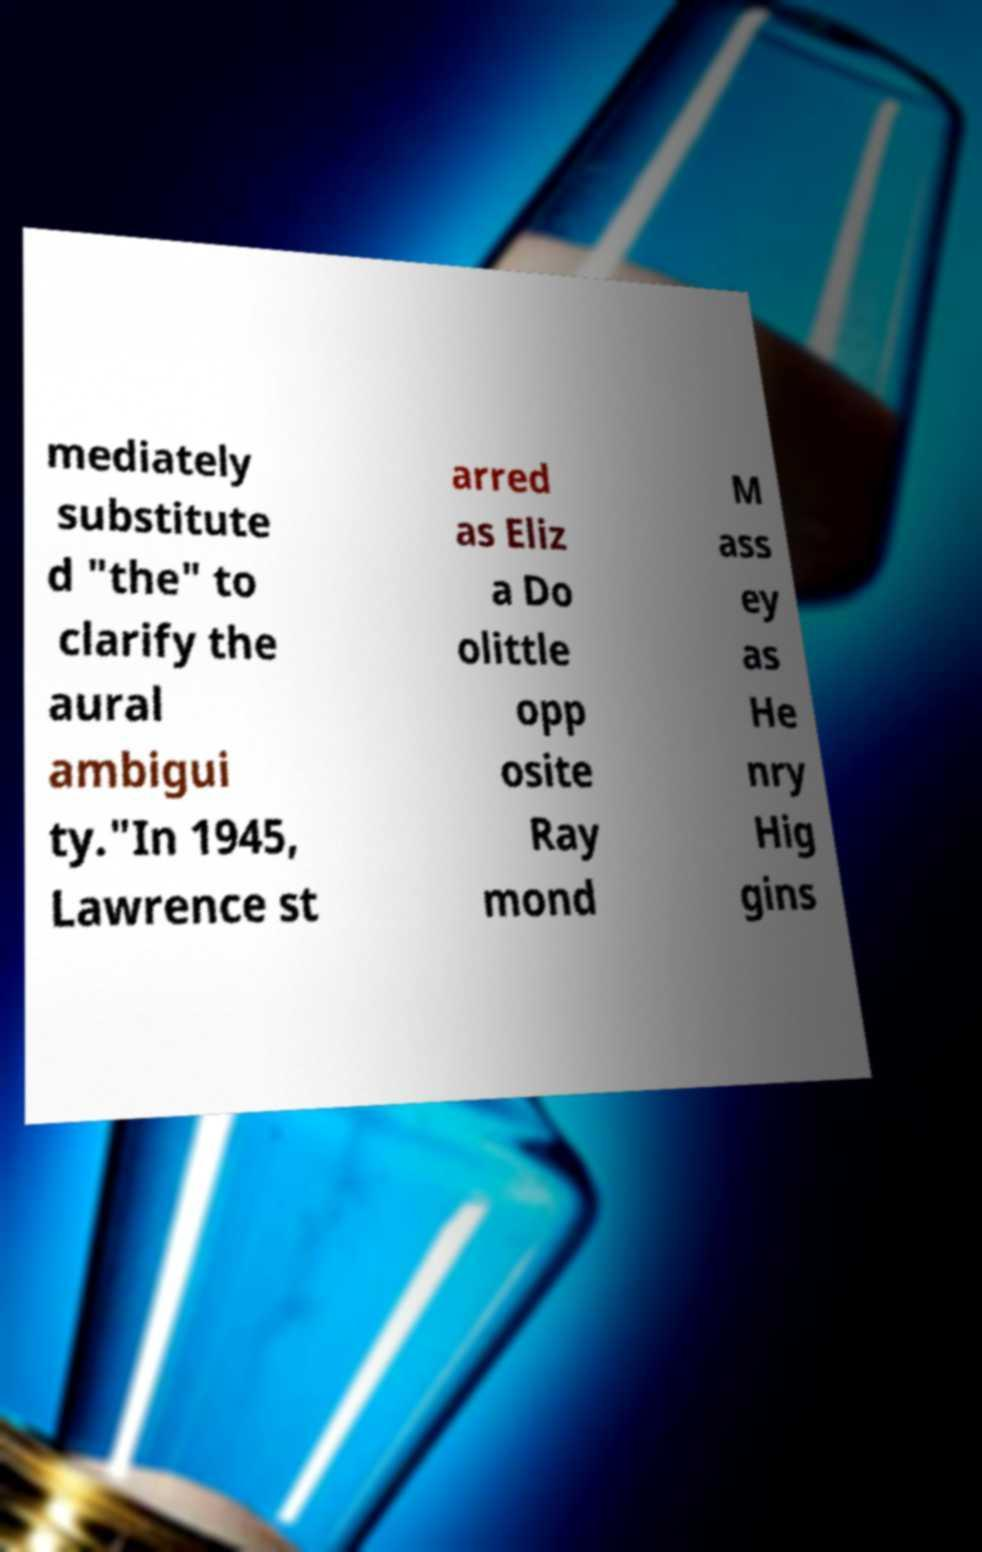Can you accurately transcribe the text from the provided image for me? mediately substitute d "the" to clarify the aural ambigui ty."In 1945, Lawrence st arred as Eliz a Do olittle opp osite Ray mond M ass ey as He nry Hig gins 